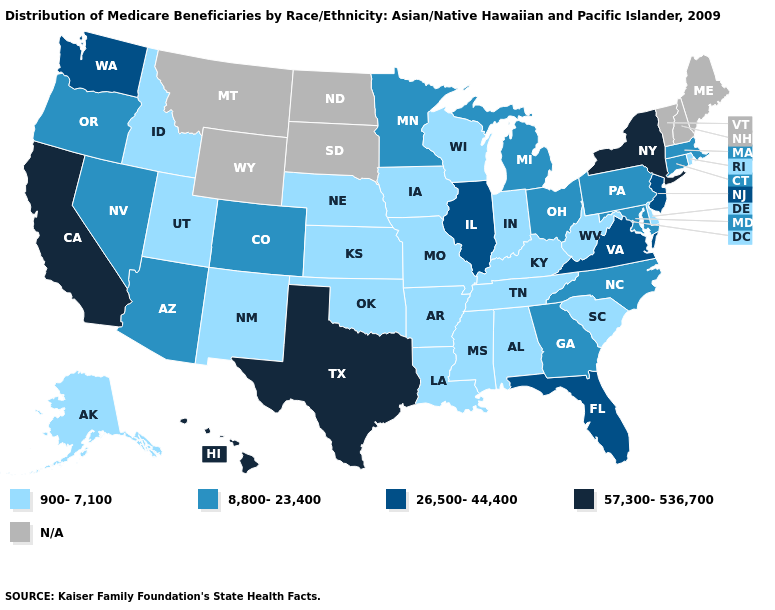What is the highest value in the USA?
Be succinct. 57,300-536,700. What is the value of Tennessee?
Give a very brief answer. 900-7,100. Is the legend a continuous bar?
Write a very short answer. No. Name the states that have a value in the range 57,300-536,700?
Be succinct. California, Hawaii, New York, Texas. Name the states that have a value in the range 900-7,100?
Be succinct. Alabama, Alaska, Arkansas, Delaware, Idaho, Indiana, Iowa, Kansas, Kentucky, Louisiana, Mississippi, Missouri, Nebraska, New Mexico, Oklahoma, Rhode Island, South Carolina, Tennessee, Utah, West Virginia, Wisconsin. Which states have the highest value in the USA?
Concise answer only. California, Hawaii, New York, Texas. Does Minnesota have the lowest value in the MidWest?
Give a very brief answer. No. Does Pennsylvania have the highest value in the Northeast?
Keep it brief. No. Among the states that border Georgia , does Alabama have the lowest value?
Be succinct. Yes. Name the states that have a value in the range 26,500-44,400?
Answer briefly. Florida, Illinois, New Jersey, Virginia, Washington. Among the states that border Iowa , which have the lowest value?
Give a very brief answer. Missouri, Nebraska, Wisconsin. Among the states that border Kansas , does Nebraska have the lowest value?
Keep it brief. Yes. What is the lowest value in states that border Maryland?
Quick response, please. 900-7,100. How many symbols are there in the legend?
Keep it brief. 5. 